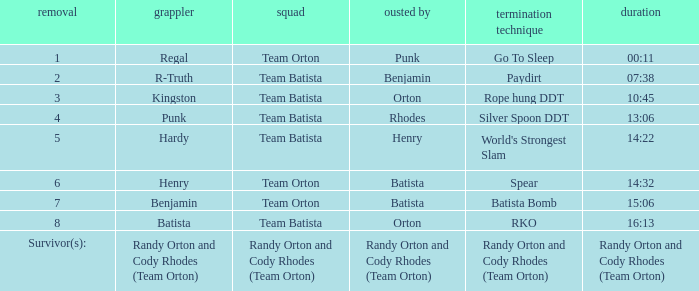Which Elimination Move is listed at Elimination 8 for Team Batista? RKO. 